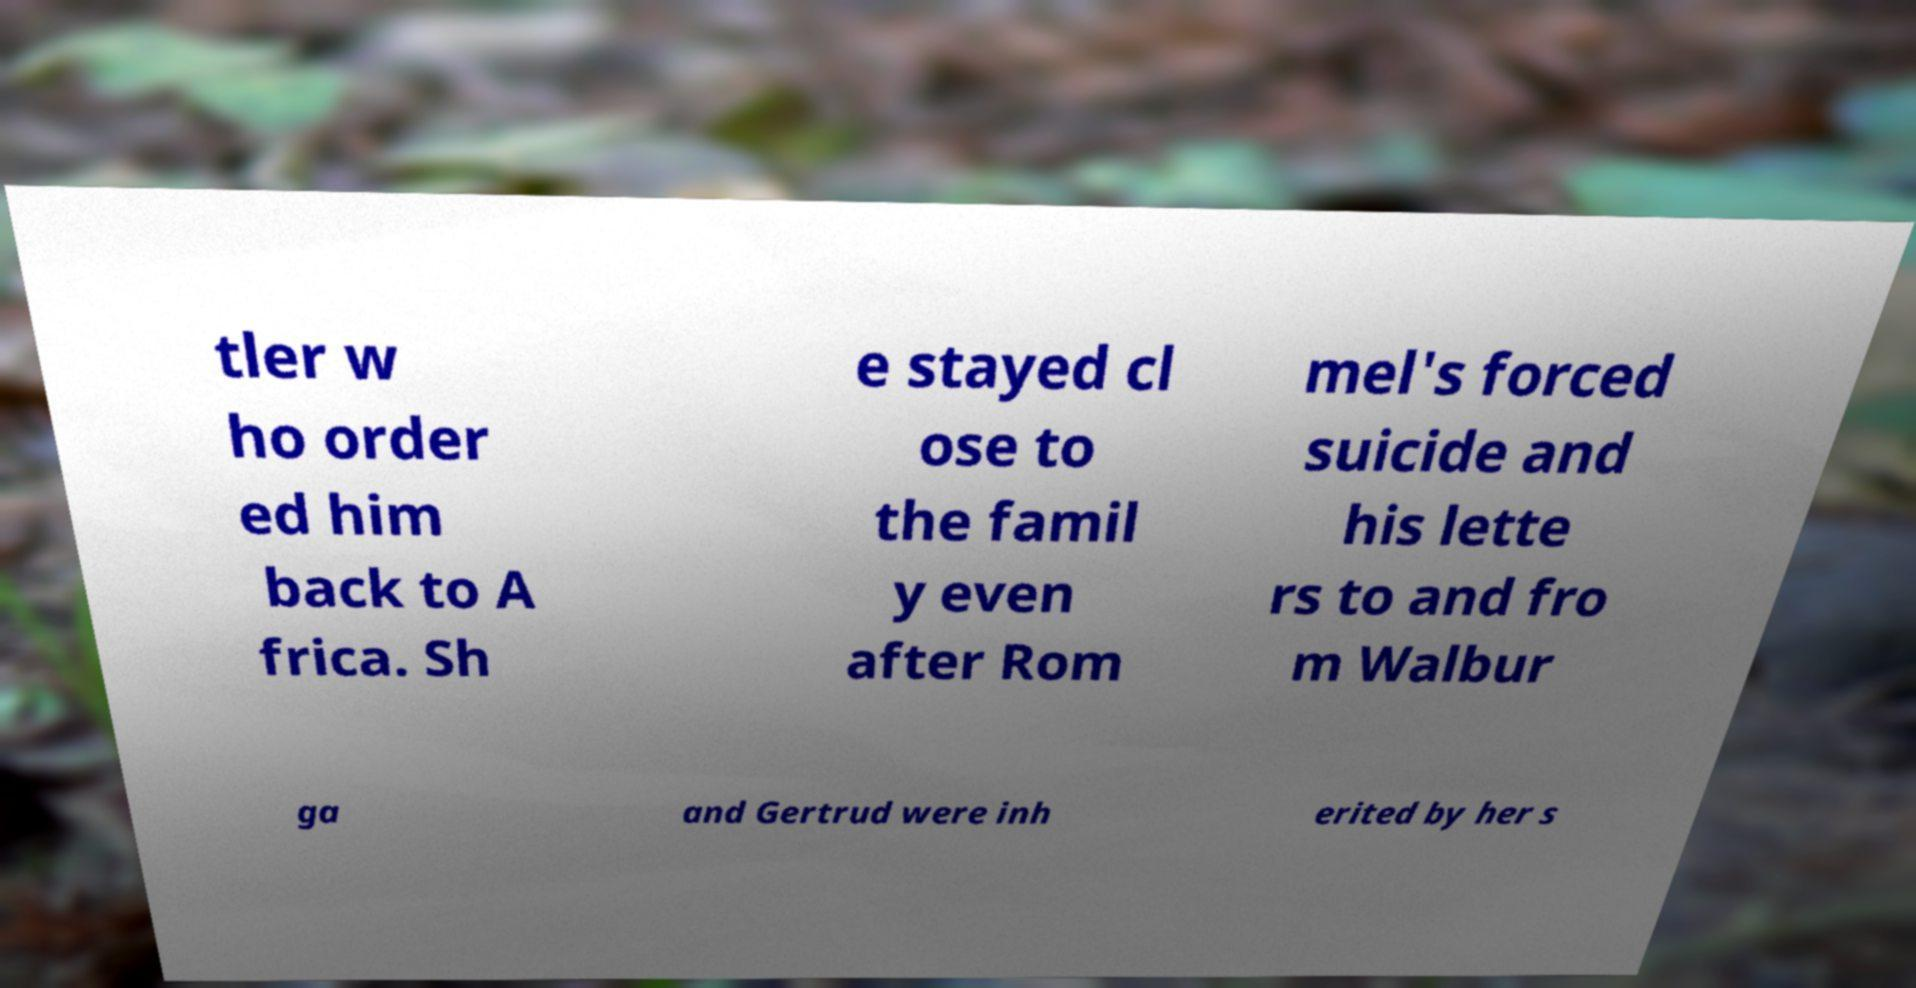For documentation purposes, I need the text within this image transcribed. Could you provide that? tler w ho order ed him back to A frica. Sh e stayed cl ose to the famil y even after Rom mel's forced suicide and his lette rs to and fro m Walbur ga and Gertrud were inh erited by her s 